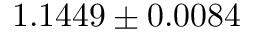<formula> <loc_0><loc_0><loc_500><loc_500>1 . 1 4 4 9 \pm 0 . 0 0 8 4</formula> 